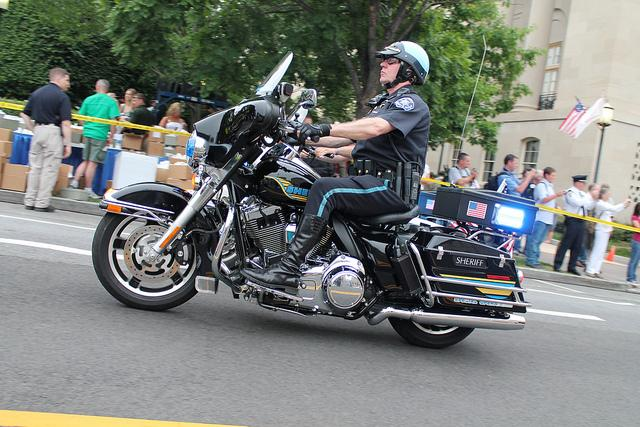What is the name of the nation with the flag in this picture? united states 